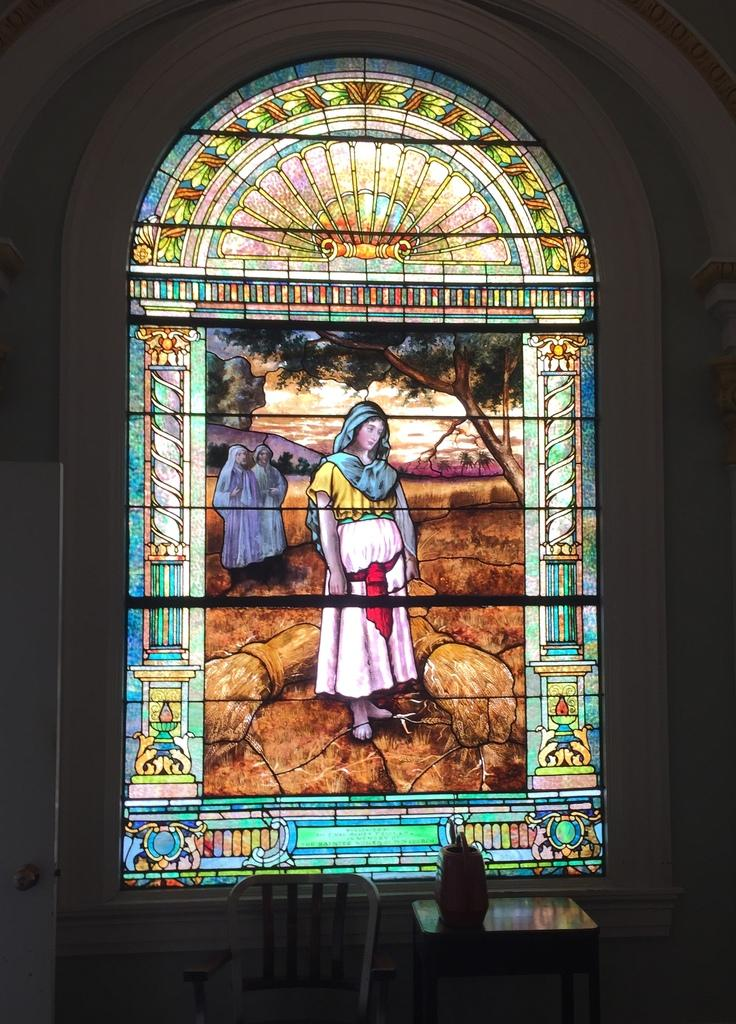What type of glass can be seen in the image? There is a stained glass in the image. What type of furniture is present in the image? There is a chair in the image. What type of flame can be seen coming from the vase in the image? There is no vase or flame present in the image. What type of crack is visible on the stained glass in the image? There is no crack visible on the stained glass in the image. 